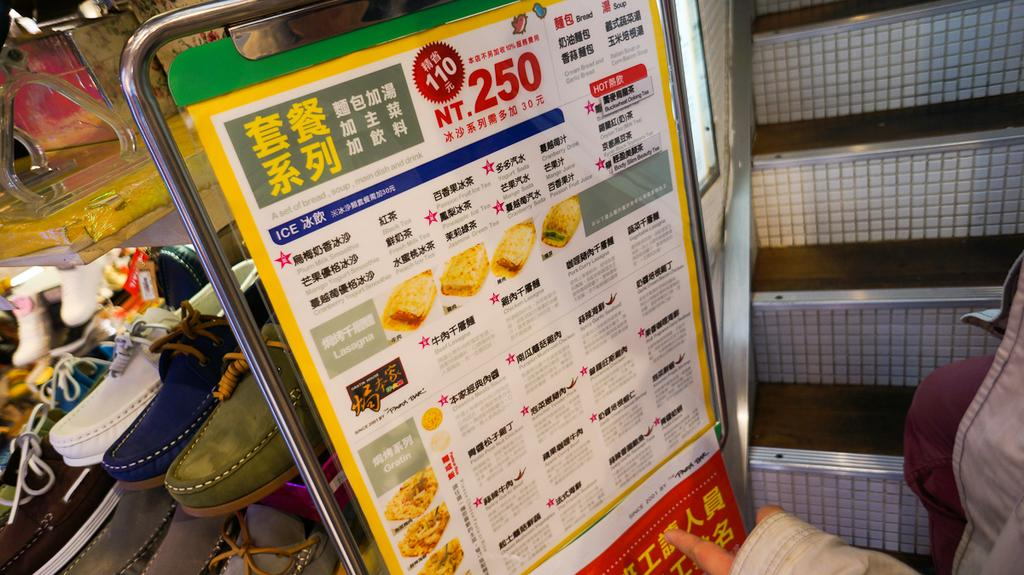What types of items are displayed on the shelves in the image? There are different kinds of shoes in the image. How are the shoes arranged on the shelves? The shoes are arranged on shelves. Can you describe the person standing in the image? There is a person standing in the image, but no specific details about their appearance or actions are provided. What architectural feature is visible in the image? A staircase is visible in the image. What might provide information or guidance in the image? There is an information board in the image. What type of bird is sitting on the person's shoulder in the image? There is no bird present in the image; only shoes, shelves, a person, a staircase, and an information board are visible. 